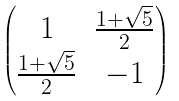Convert formula to latex. <formula><loc_0><loc_0><loc_500><loc_500>\begin{pmatrix} 1 & \frac { 1 + \sqrt { 5 } } 2 \\ \frac { 1 + \sqrt { 5 } } 2 & - 1 \end{pmatrix}</formula> 